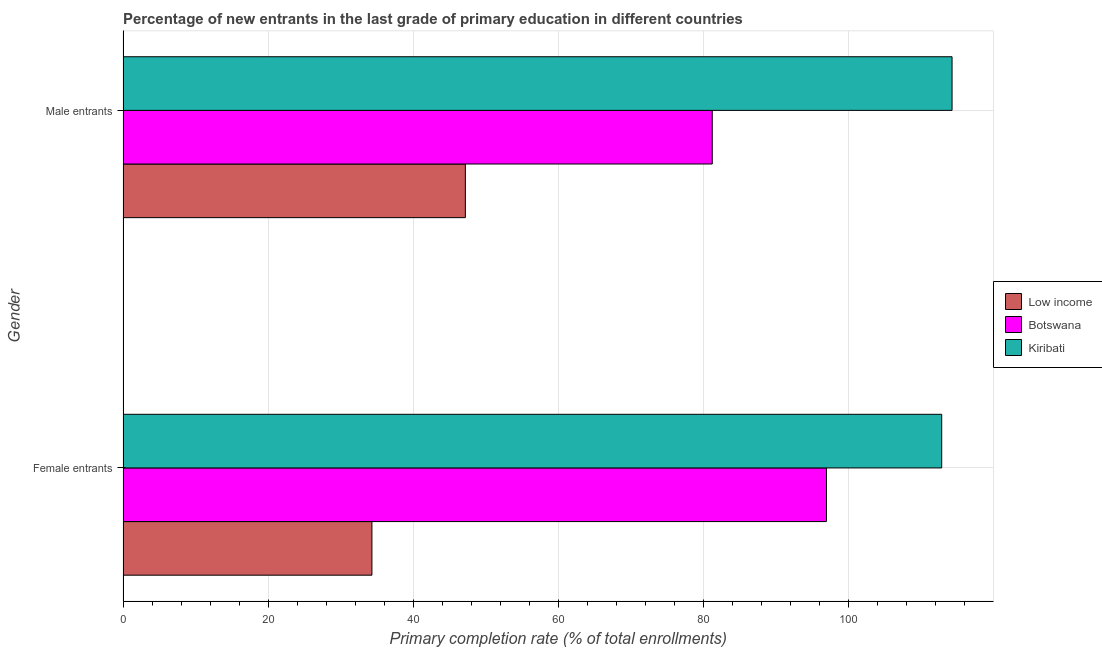How many different coloured bars are there?
Provide a succinct answer. 3. How many groups of bars are there?
Provide a short and direct response. 2. How many bars are there on the 1st tick from the top?
Give a very brief answer. 3. How many bars are there on the 2nd tick from the bottom?
Keep it short and to the point. 3. What is the label of the 1st group of bars from the top?
Offer a terse response. Male entrants. What is the primary completion rate of male entrants in Botswana?
Your answer should be very brief. 81.21. Across all countries, what is the maximum primary completion rate of female entrants?
Keep it short and to the point. 112.82. Across all countries, what is the minimum primary completion rate of male entrants?
Offer a very short reply. 47.18. In which country was the primary completion rate of male entrants maximum?
Your answer should be compact. Kiribati. What is the total primary completion rate of female entrants in the graph?
Provide a short and direct response. 244.07. What is the difference between the primary completion rate of male entrants in Low income and that in Botswana?
Ensure brevity in your answer.  -34.02. What is the difference between the primary completion rate of female entrants in Low income and the primary completion rate of male entrants in Kiribati?
Your response must be concise. -79.95. What is the average primary completion rate of male entrants per country?
Keep it short and to the point. 80.88. What is the difference between the primary completion rate of male entrants and primary completion rate of female entrants in Low income?
Give a very brief answer. 12.88. What is the ratio of the primary completion rate of male entrants in Botswana to that in Kiribati?
Offer a terse response. 0.71. Is the primary completion rate of female entrants in Kiribati less than that in Low income?
Offer a very short reply. No. What does the 3rd bar from the top in Female entrants represents?
Provide a succinct answer. Low income. What does the 2nd bar from the bottom in Female entrants represents?
Your answer should be very brief. Botswana. How many bars are there?
Provide a short and direct response. 6. What is the difference between two consecutive major ticks on the X-axis?
Ensure brevity in your answer.  20. Does the graph contain grids?
Provide a short and direct response. Yes. How are the legend labels stacked?
Keep it short and to the point. Vertical. What is the title of the graph?
Provide a short and direct response. Percentage of new entrants in the last grade of primary education in different countries. What is the label or title of the X-axis?
Provide a short and direct response. Primary completion rate (% of total enrollments). What is the Primary completion rate (% of total enrollments) in Low income in Female entrants?
Keep it short and to the point. 34.3. What is the Primary completion rate (% of total enrollments) of Botswana in Female entrants?
Offer a very short reply. 96.94. What is the Primary completion rate (% of total enrollments) of Kiribati in Female entrants?
Provide a short and direct response. 112.82. What is the Primary completion rate (% of total enrollments) in Low income in Male entrants?
Provide a succinct answer. 47.18. What is the Primary completion rate (% of total enrollments) in Botswana in Male entrants?
Your answer should be compact. 81.21. What is the Primary completion rate (% of total enrollments) of Kiribati in Male entrants?
Provide a short and direct response. 114.25. Across all Gender, what is the maximum Primary completion rate (% of total enrollments) of Low income?
Offer a very short reply. 47.18. Across all Gender, what is the maximum Primary completion rate (% of total enrollments) of Botswana?
Ensure brevity in your answer.  96.94. Across all Gender, what is the maximum Primary completion rate (% of total enrollments) of Kiribati?
Give a very brief answer. 114.25. Across all Gender, what is the minimum Primary completion rate (% of total enrollments) in Low income?
Provide a short and direct response. 34.3. Across all Gender, what is the minimum Primary completion rate (% of total enrollments) in Botswana?
Your response must be concise. 81.21. Across all Gender, what is the minimum Primary completion rate (% of total enrollments) in Kiribati?
Provide a succinct answer. 112.82. What is the total Primary completion rate (% of total enrollments) of Low income in the graph?
Provide a succinct answer. 81.48. What is the total Primary completion rate (% of total enrollments) in Botswana in the graph?
Give a very brief answer. 178.15. What is the total Primary completion rate (% of total enrollments) of Kiribati in the graph?
Give a very brief answer. 227.07. What is the difference between the Primary completion rate (% of total enrollments) in Low income in Female entrants and that in Male entrants?
Your answer should be compact. -12.88. What is the difference between the Primary completion rate (% of total enrollments) in Botswana in Female entrants and that in Male entrants?
Offer a very short reply. 15.74. What is the difference between the Primary completion rate (% of total enrollments) in Kiribati in Female entrants and that in Male entrants?
Your response must be concise. -1.43. What is the difference between the Primary completion rate (% of total enrollments) of Low income in Female entrants and the Primary completion rate (% of total enrollments) of Botswana in Male entrants?
Your answer should be very brief. -46.9. What is the difference between the Primary completion rate (% of total enrollments) in Low income in Female entrants and the Primary completion rate (% of total enrollments) in Kiribati in Male entrants?
Give a very brief answer. -79.95. What is the difference between the Primary completion rate (% of total enrollments) of Botswana in Female entrants and the Primary completion rate (% of total enrollments) of Kiribati in Male entrants?
Give a very brief answer. -17.31. What is the average Primary completion rate (% of total enrollments) in Low income per Gender?
Keep it short and to the point. 40.74. What is the average Primary completion rate (% of total enrollments) in Botswana per Gender?
Provide a succinct answer. 89.07. What is the average Primary completion rate (% of total enrollments) of Kiribati per Gender?
Offer a terse response. 113.54. What is the difference between the Primary completion rate (% of total enrollments) in Low income and Primary completion rate (% of total enrollments) in Botswana in Female entrants?
Your answer should be very brief. -62.64. What is the difference between the Primary completion rate (% of total enrollments) in Low income and Primary completion rate (% of total enrollments) in Kiribati in Female entrants?
Your answer should be very brief. -78.52. What is the difference between the Primary completion rate (% of total enrollments) in Botswana and Primary completion rate (% of total enrollments) in Kiribati in Female entrants?
Provide a short and direct response. -15.88. What is the difference between the Primary completion rate (% of total enrollments) of Low income and Primary completion rate (% of total enrollments) of Botswana in Male entrants?
Ensure brevity in your answer.  -34.02. What is the difference between the Primary completion rate (% of total enrollments) in Low income and Primary completion rate (% of total enrollments) in Kiribati in Male entrants?
Give a very brief answer. -67.07. What is the difference between the Primary completion rate (% of total enrollments) of Botswana and Primary completion rate (% of total enrollments) of Kiribati in Male entrants?
Offer a very short reply. -33.05. What is the ratio of the Primary completion rate (% of total enrollments) of Low income in Female entrants to that in Male entrants?
Provide a short and direct response. 0.73. What is the ratio of the Primary completion rate (% of total enrollments) in Botswana in Female entrants to that in Male entrants?
Your response must be concise. 1.19. What is the ratio of the Primary completion rate (% of total enrollments) of Kiribati in Female entrants to that in Male entrants?
Make the answer very short. 0.99. What is the difference between the highest and the second highest Primary completion rate (% of total enrollments) in Low income?
Provide a short and direct response. 12.88. What is the difference between the highest and the second highest Primary completion rate (% of total enrollments) in Botswana?
Your answer should be compact. 15.74. What is the difference between the highest and the second highest Primary completion rate (% of total enrollments) of Kiribati?
Your answer should be compact. 1.43. What is the difference between the highest and the lowest Primary completion rate (% of total enrollments) of Low income?
Ensure brevity in your answer.  12.88. What is the difference between the highest and the lowest Primary completion rate (% of total enrollments) of Botswana?
Provide a short and direct response. 15.74. What is the difference between the highest and the lowest Primary completion rate (% of total enrollments) in Kiribati?
Offer a very short reply. 1.43. 